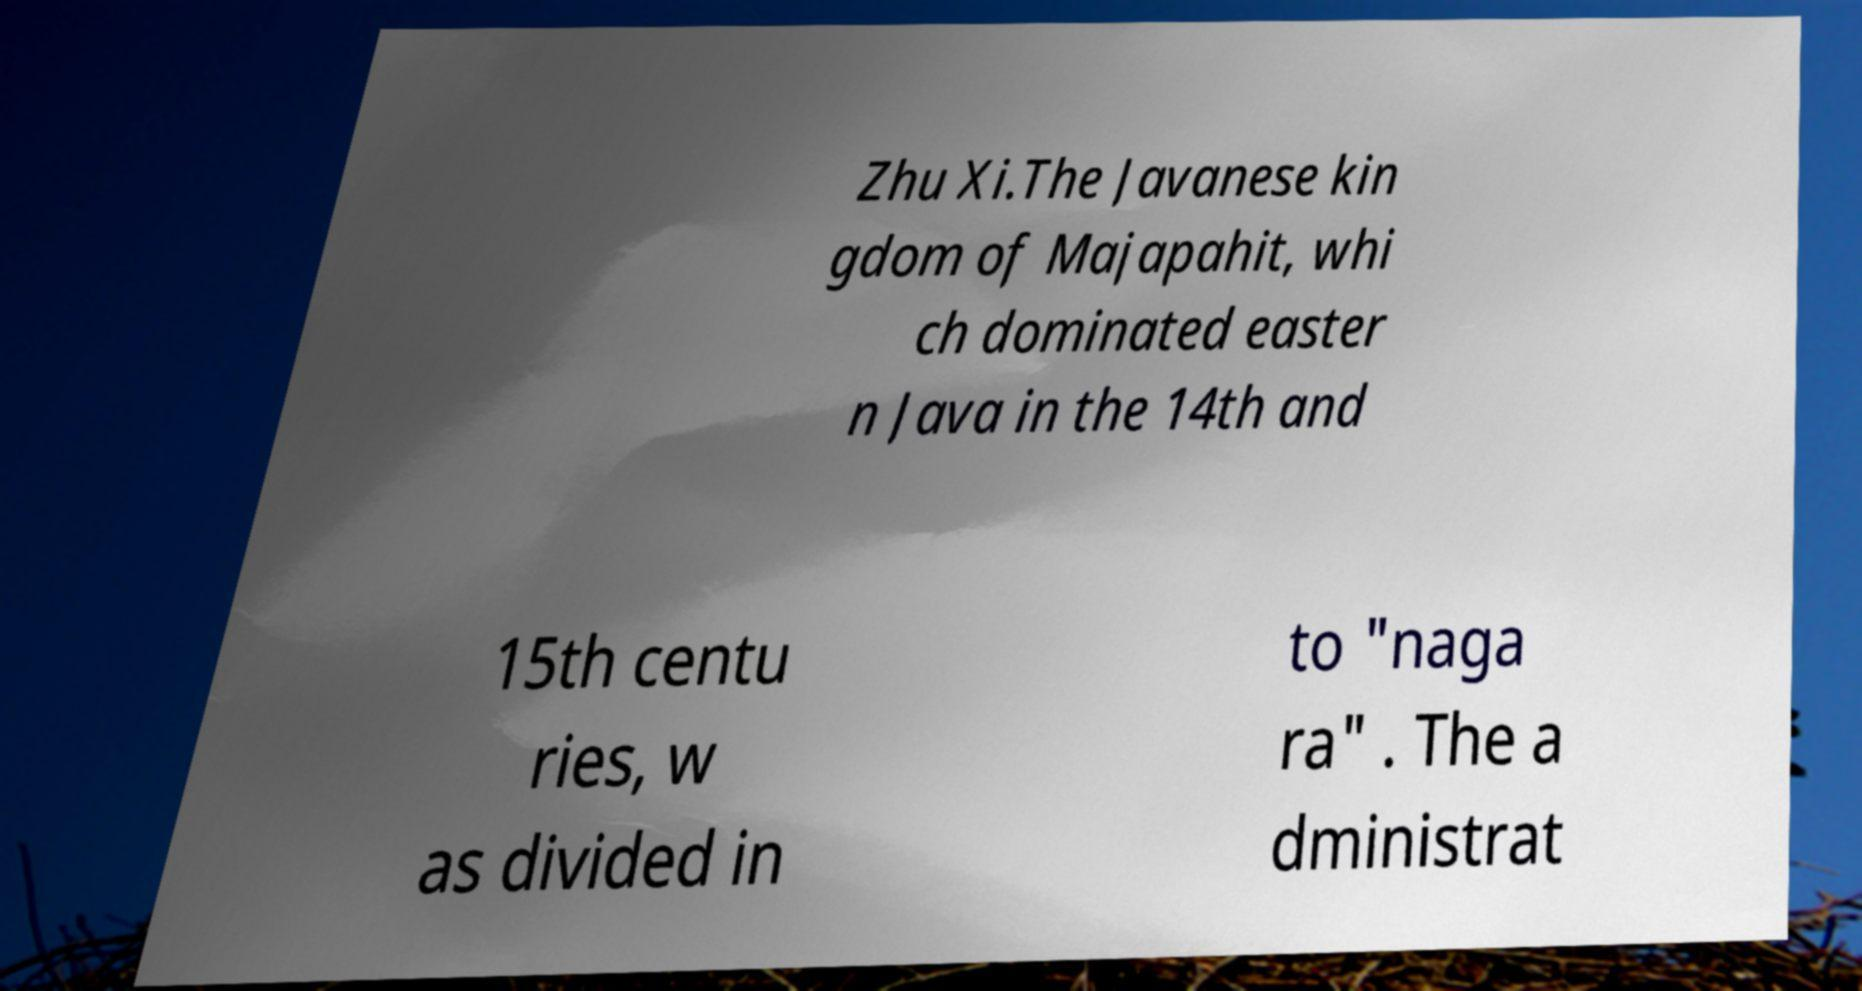Can you accurately transcribe the text from the provided image for me? Zhu Xi.The Javanese kin gdom of Majapahit, whi ch dominated easter n Java in the 14th and 15th centu ries, w as divided in to "naga ra" . The a dministrat 